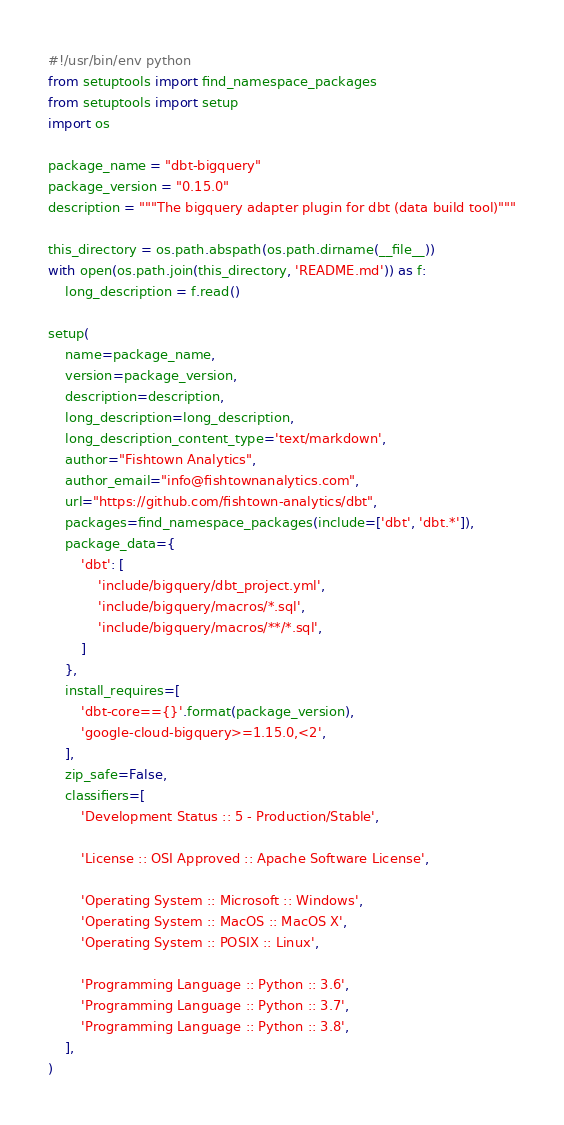<code> <loc_0><loc_0><loc_500><loc_500><_Python_>#!/usr/bin/env python
from setuptools import find_namespace_packages
from setuptools import setup
import os

package_name = "dbt-bigquery"
package_version = "0.15.0"
description = """The bigquery adapter plugin for dbt (data build tool)"""

this_directory = os.path.abspath(os.path.dirname(__file__))
with open(os.path.join(this_directory, 'README.md')) as f:
    long_description = f.read()

setup(
    name=package_name,
    version=package_version,
    description=description,
    long_description=long_description,
    long_description_content_type='text/markdown',
    author="Fishtown Analytics",
    author_email="info@fishtownanalytics.com",
    url="https://github.com/fishtown-analytics/dbt",
    packages=find_namespace_packages(include=['dbt', 'dbt.*']),
    package_data={
        'dbt': [
            'include/bigquery/dbt_project.yml',
            'include/bigquery/macros/*.sql',
            'include/bigquery/macros/**/*.sql',
        ]
    },
    install_requires=[
        'dbt-core=={}'.format(package_version),
        'google-cloud-bigquery>=1.15.0,<2',
    ],
    zip_safe=False,
    classifiers=[
        'Development Status :: 5 - Production/Stable',

        'License :: OSI Approved :: Apache Software License',

        'Operating System :: Microsoft :: Windows',
        'Operating System :: MacOS :: MacOS X',
        'Operating System :: POSIX :: Linux',

        'Programming Language :: Python :: 3.6',
        'Programming Language :: Python :: 3.7',
        'Programming Language :: Python :: 3.8',
    ],
)
</code> 